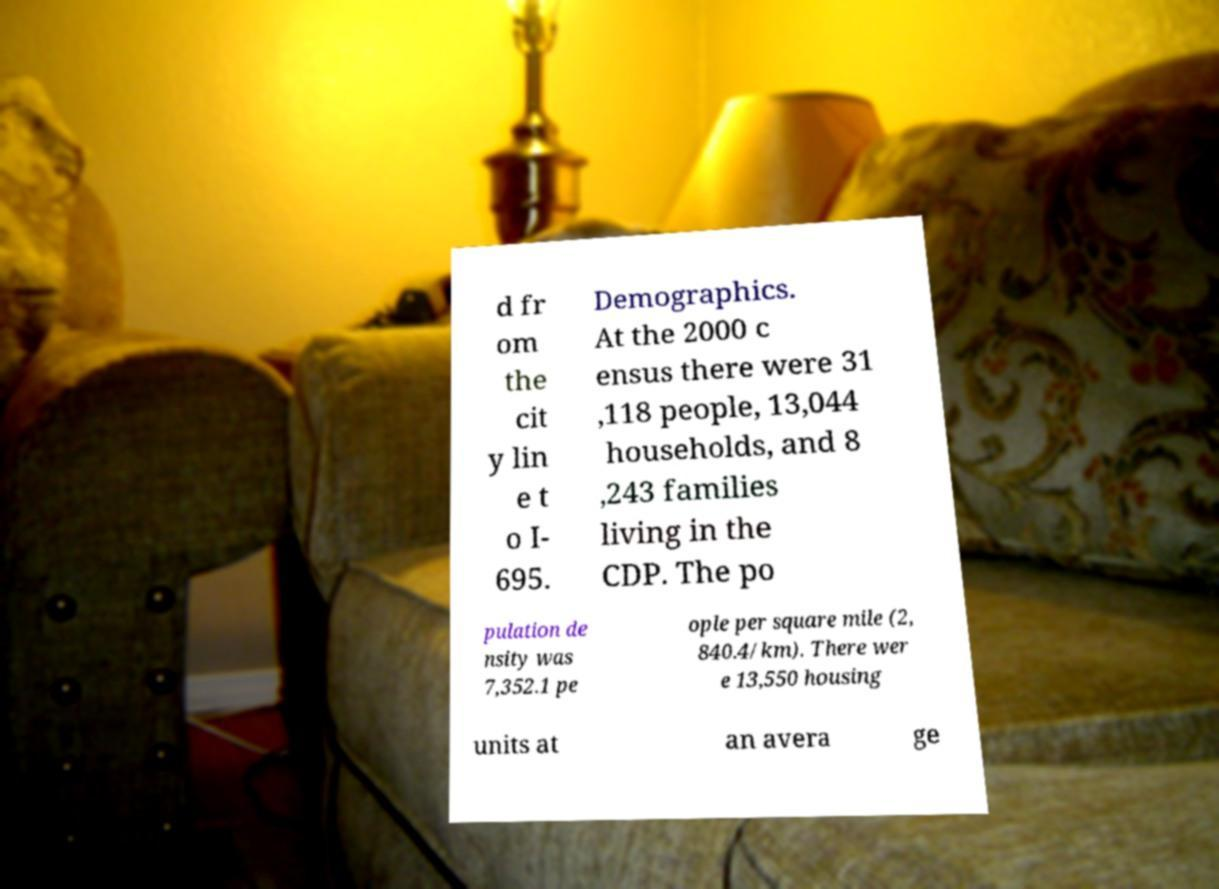Could you extract and type out the text from this image? d fr om the cit y lin e t o I- 695. Demographics. At the 2000 c ensus there were 31 ,118 people, 13,044 households, and 8 ,243 families living in the CDP. The po pulation de nsity was 7,352.1 pe ople per square mile (2, 840.4/km). There wer e 13,550 housing units at an avera ge 